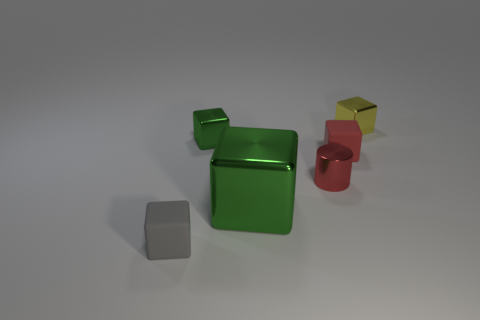What might be the function of these objects? These objects could potentially be simplistic models or representations used for educational purposes, such as demonstrating geometry or teaching about colors and materials in a classroom setting. 